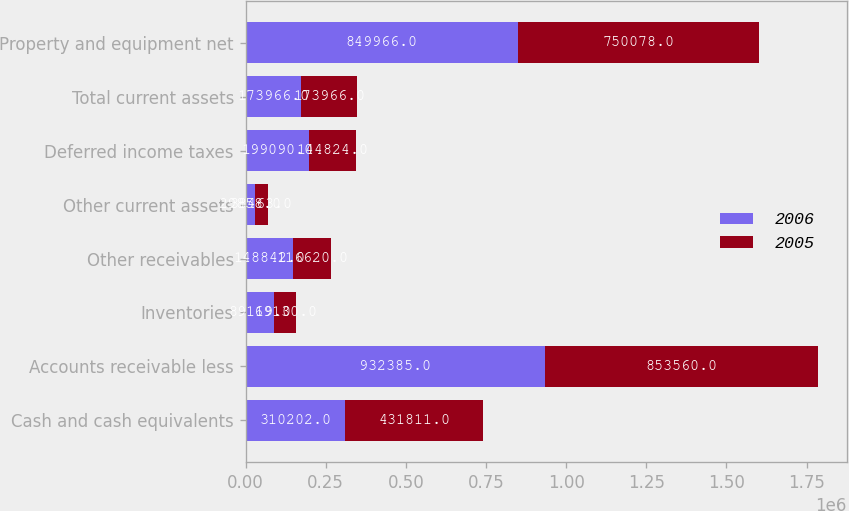Convert chart. <chart><loc_0><loc_0><loc_500><loc_500><stacked_bar_chart><ecel><fcel>Cash and cash equivalents<fcel>Accounts receivable less<fcel>Inventories<fcel>Other receivables<fcel>Other current assets<fcel>Deferred income taxes<fcel>Total current assets<fcel>Property and equipment net<nl><fcel>2006<fcel>310202<fcel>932385<fcel>89119<fcel>148842<fcel>29858<fcel>199090<fcel>173966<fcel>849966<nl><fcel>2005<fcel>431811<fcel>853560<fcel>69130<fcel>116620<fcel>38463<fcel>144824<fcel>173966<fcel>750078<nl></chart> 